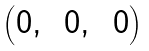<formula> <loc_0><loc_0><loc_500><loc_500>\begin{pmatrix} 0 , & \, 0 , & \, 0 \end{pmatrix}</formula> 